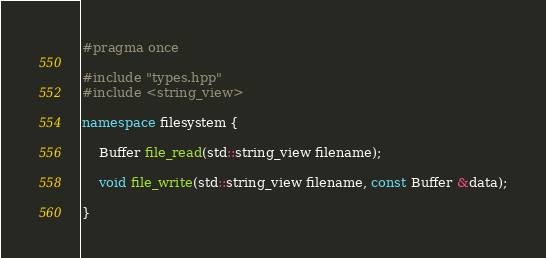Convert code to text. <code><loc_0><loc_0><loc_500><loc_500><_C++_>#pragma once

#include "types.hpp"
#include <string_view>

namespace filesystem {

	Buffer file_read(std::string_view filename);

	void file_write(std::string_view filename, const Buffer &data);

}
</code> 